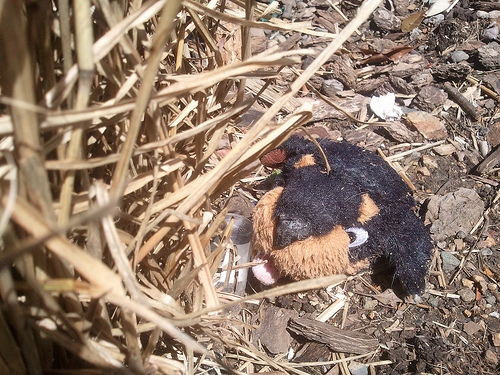<image>
Can you confirm if the dog is in the mulch? Yes. The dog is contained within or inside the mulch, showing a containment relationship. 